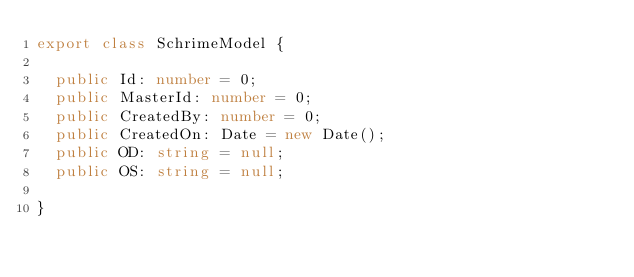<code> <loc_0><loc_0><loc_500><loc_500><_TypeScript_>export class SchrimeModel {

  public Id: number = 0;
  public MasterId: number = 0;
  public CreatedBy: number = 0;
  public CreatedOn: Date = new Date();
  public OD: string = null;
  public OS: string = null;

}
</code> 